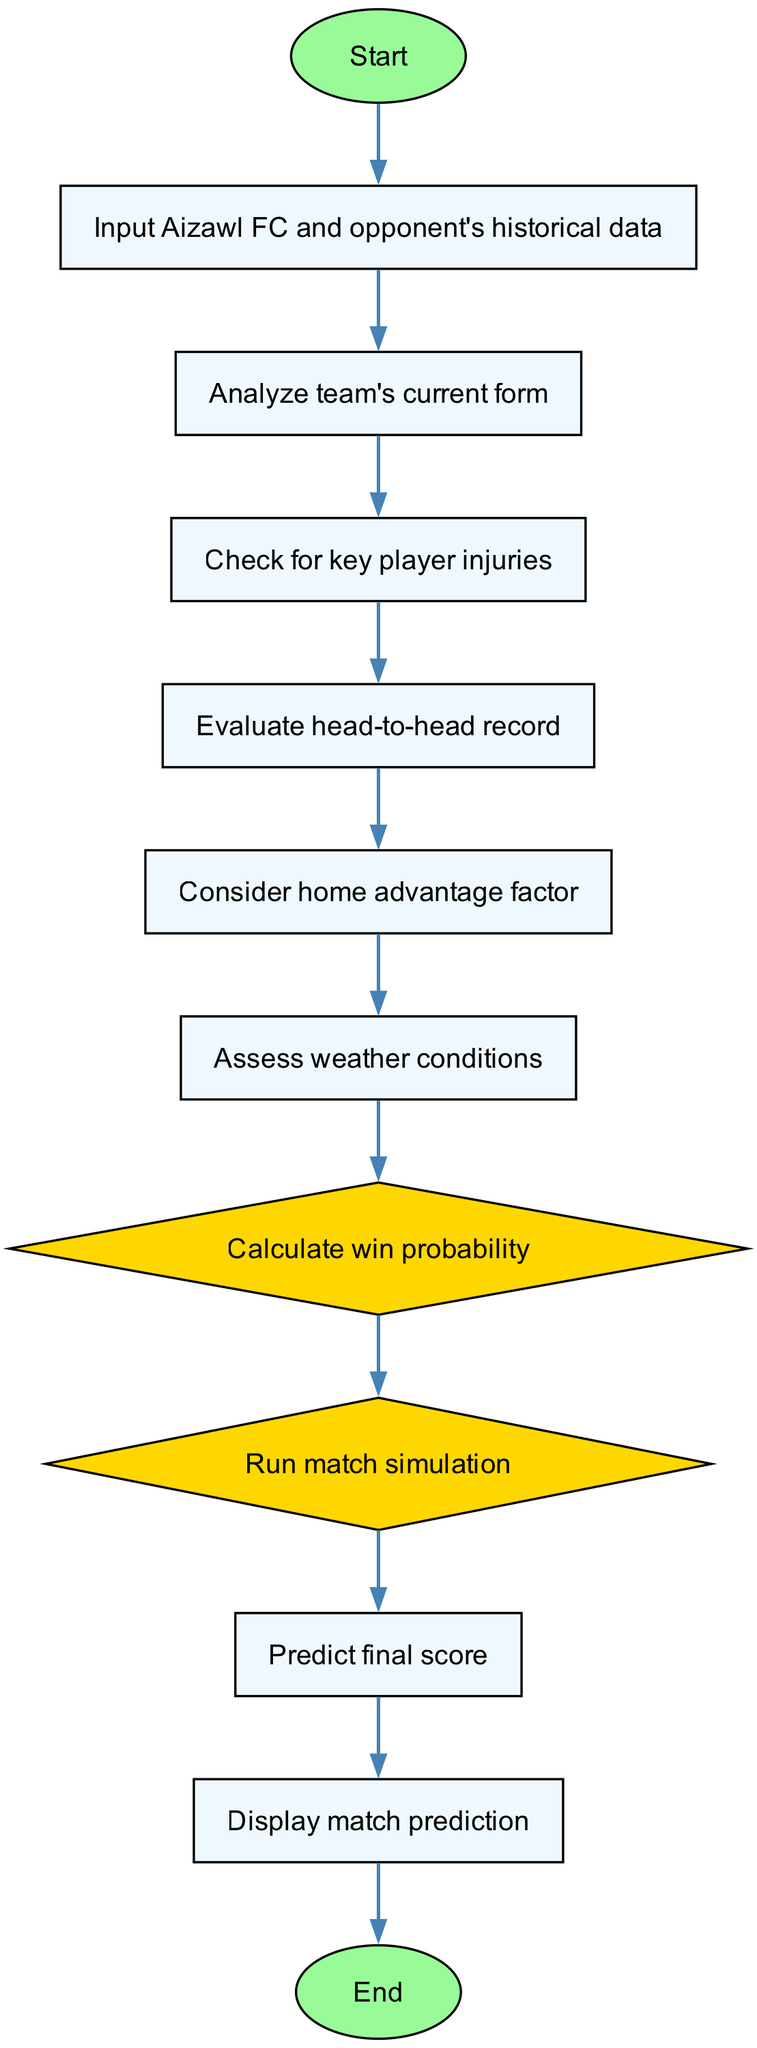What is the starting point of the flowchart? The starting point of the flowchart is labeled as "Start". This is the first node in the diagram and indicates where the process begins.
Answer: Start What is the last step before displaying the result? The step right before displaying the result is "Predict final score". It outlines the action taken just prior to displaying the match prediction.
Answer: Predict final score How many nodes are there in total? The total number of nodes includes all the elements from start to end, which amounts to 12 nodes in this flowchart.
Answer: 12 What action is taken after analyzing the team's current form? After analyzing the team's current form, the next action is "Check for key player injuries". This shows the sequential steps in the prediction process.
Answer: Check for key player injuries What factor is considered after evaluating the head-to-head record? Following the evaluation of the head-to-head record, "Consider home advantage factor" is taken into account. This maintains the logical flow of the decision-making process.
Answer: Consider home advantage factor In how many steps does the simulation occur? The match simulation occurs in one specific step labeled "Run match simulation". This step illustrates the point at which the algorithm simulates the match.
Answer: 1 What is the shape of the node used for calculating probability? The node used for calculating probability is shaped like a diamond. This shape often represents a decision-making point in flowchart diagrams.
Answer: Diamond Which step assesses external conditions affecting the match? The step that assesses external conditions affecting the match is "Assess weather conditions". It indicates the consideration of factors that may influence the match outcome.
Answer: Assess weather conditions Is the "Display match prediction" step connected directly to the "End" step? Yes, the "Display match prediction" step is directly connected to the "End" step. This means displaying the prediction is the final action taken before concluding the process.
Answer: Yes 